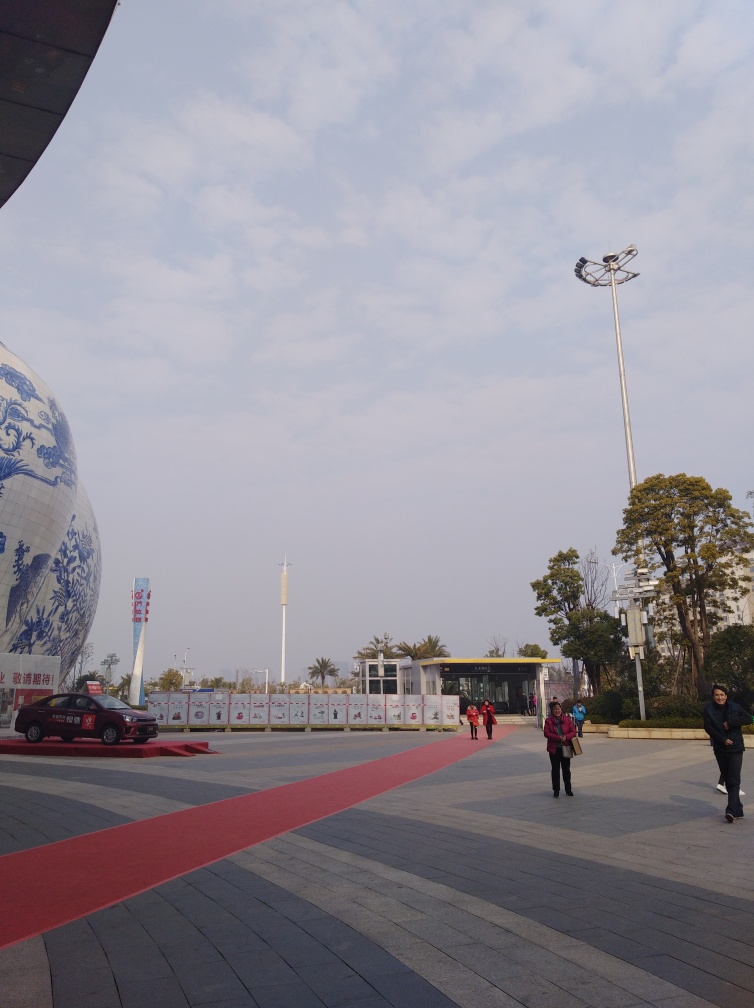Can you describe the atmosphere of the place shown in the image? The atmosphere appears calm and composed, with a spacious plaza inviting leisurely strolls. The clear skies suggest good weather and a serene vibe. The large ornamented sphere and structured building in the background hint at cultural significance, likely a place where visitors come to appreciate art or history. 